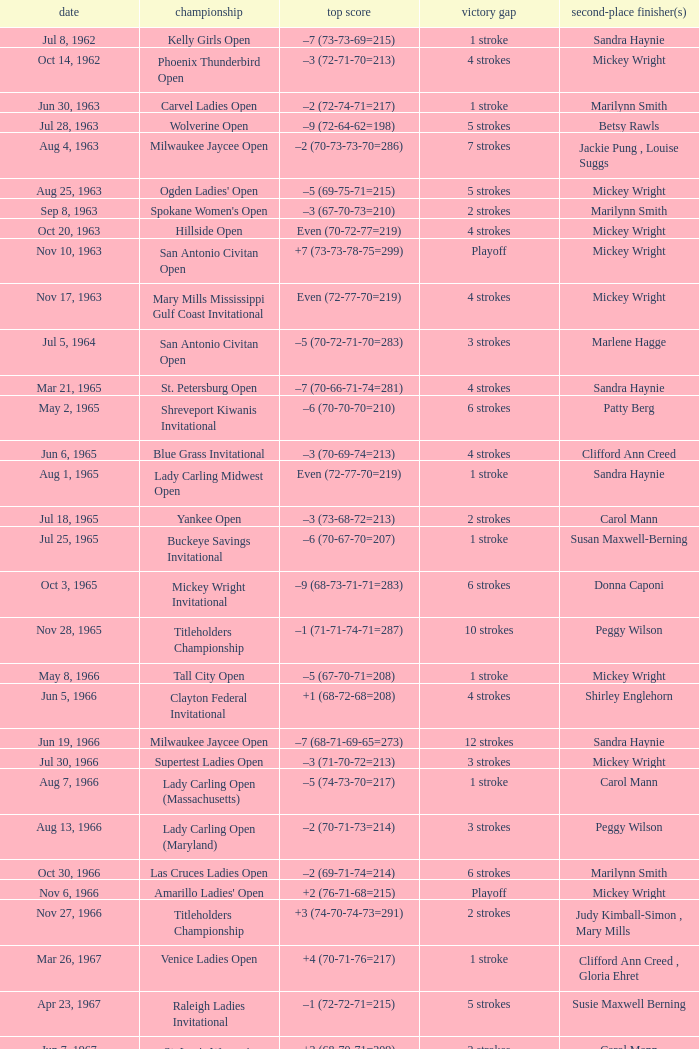How much did the winner surpass the runner-up by on april 23, 1967? 5 strokes. Could you parse the entire table as a dict? {'header': ['date', 'championship', 'top score', 'victory gap', 'second-place finisher(s)'], 'rows': [['Jul 8, 1962', 'Kelly Girls Open', '–7 (73-73-69=215)', '1 stroke', 'Sandra Haynie'], ['Oct 14, 1962', 'Phoenix Thunderbird Open', '–3 (72-71-70=213)', '4 strokes', 'Mickey Wright'], ['Jun 30, 1963', 'Carvel Ladies Open', '–2 (72-74-71=217)', '1 stroke', 'Marilynn Smith'], ['Jul 28, 1963', 'Wolverine Open', '–9 (72-64-62=198)', '5 strokes', 'Betsy Rawls'], ['Aug 4, 1963', 'Milwaukee Jaycee Open', '–2 (70-73-73-70=286)', '7 strokes', 'Jackie Pung , Louise Suggs'], ['Aug 25, 1963', "Ogden Ladies' Open", '–5 (69-75-71=215)', '5 strokes', 'Mickey Wright'], ['Sep 8, 1963', "Spokane Women's Open", '–3 (67-70-73=210)', '2 strokes', 'Marilynn Smith'], ['Oct 20, 1963', 'Hillside Open', 'Even (70-72-77=219)', '4 strokes', 'Mickey Wright'], ['Nov 10, 1963', 'San Antonio Civitan Open', '+7 (73-73-78-75=299)', 'Playoff', 'Mickey Wright'], ['Nov 17, 1963', 'Mary Mills Mississippi Gulf Coast Invitational', 'Even (72-77-70=219)', '4 strokes', 'Mickey Wright'], ['Jul 5, 1964', 'San Antonio Civitan Open', '–5 (70-72-71-70=283)', '3 strokes', 'Marlene Hagge'], ['Mar 21, 1965', 'St. Petersburg Open', '–7 (70-66-71-74=281)', '4 strokes', 'Sandra Haynie'], ['May 2, 1965', 'Shreveport Kiwanis Invitational', '–6 (70-70-70=210)', '6 strokes', 'Patty Berg'], ['Jun 6, 1965', 'Blue Grass Invitational', '–3 (70-69-74=213)', '4 strokes', 'Clifford Ann Creed'], ['Aug 1, 1965', 'Lady Carling Midwest Open', 'Even (72-77-70=219)', '1 stroke', 'Sandra Haynie'], ['Jul 18, 1965', 'Yankee Open', '–3 (73-68-72=213)', '2 strokes', 'Carol Mann'], ['Jul 25, 1965', 'Buckeye Savings Invitational', '–6 (70-67-70=207)', '1 stroke', 'Susan Maxwell-Berning'], ['Oct 3, 1965', 'Mickey Wright Invitational', '–9 (68-73-71-71=283)', '6 strokes', 'Donna Caponi'], ['Nov 28, 1965', 'Titleholders Championship', '–1 (71-71-74-71=287)', '10 strokes', 'Peggy Wilson'], ['May 8, 1966', 'Tall City Open', '–5 (67-70-71=208)', '1 stroke', 'Mickey Wright'], ['Jun 5, 1966', 'Clayton Federal Invitational', '+1 (68-72-68=208)', '4 strokes', 'Shirley Englehorn'], ['Jun 19, 1966', 'Milwaukee Jaycee Open', '–7 (68-71-69-65=273)', '12 strokes', 'Sandra Haynie'], ['Jul 30, 1966', 'Supertest Ladies Open', '–3 (71-70-72=213)', '3 strokes', 'Mickey Wright'], ['Aug 7, 1966', 'Lady Carling Open (Massachusetts)', '–5 (74-73-70=217)', '1 stroke', 'Carol Mann'], ['Aug 13, 1966', 'Lady Carling Open (Maryland)', '–2 (70-71-73=214)', '3 strokes', 'Peggy Wilson'], ['Oct 30, 1966', 'Las Cruces Ladies Open', '–2 (69-71-74=214)', '6 strokes', 'Marilynn Smith'], ['Nov 6, 1966', "Amarillo Ladies' Open", '+2 (76-71-68=215)', 'Playoff', 'Mickey Wright'], ['Nov 27, 1966', 'Titleholders Championship', '+3 (74-70-74-73=291)', '2 strokes', 'Judy Kimball-Simon , Mary Mills'], ['Mar 26, 1967', 'Venice Ladies Open', '+4 (70-71-76=217)', '1 stroke', 'Clifford Ann Creed , Gloria Ehret'], ['Apr 23, 1967', 'Raleigh Ladies Invitational', '–1 (72-72-71=215)', '5 strokes', 'Susie Maxwell Berning'], ['Jun 7, 1967', "St. Louis Women's Invitational", '+2 (68-70-71=209)', '2 strokes', 'Carol Mann'], ['Jul 16, 1967', 'LPGA Championship', '–8 (69-74-72-69=284)', '1 stroke', 'Shirley Englehorn'], ['Aug 6, 1967', 'Lady Carling Open (Ohio)', '–4 (71-70-71=212)', '1 stroke', 'Susie Maxwell Berning'], ['Aug 20, 1967', "Women's Western Open", '–11 (71-74-73-71=289)', '3 strokes', 'Sandra Haynie'], ['Oct 1, 1967', "Ladies' Los Angeles Open", '–4 (71-68-73=212)', '4 strokes', 'Murle Breer'], ['Oct 29, 1967', "Alamo Ladies' Open", '–3 (71-71-71=213)', '3 strokes', 'Sandra Haynie'], ['Mar 17, 1968', 'St. Petersburg Orange Blossom Open', 'Even (70-71-72=213)', '1 stroke', 'Sandra Haynie , Judy Kimball-Simon'], ['May 26, 1968', 'Dallas Civitan Open', '–4 (70-70-69=209)', '1 stroke', 'Carol Mann'], ['Jun 30, 1968', 'Lady Carling Open (Maryland)', '–2 (71-70-73=214)', '1 stroke', 'Carol Mann'], ['Aug 4, 1968', 'Gino Paoli Open', '–1 (69-72-74=215)', 'Playoff', 'Marlene Hagge'], ['Aug 18, 1968', 'Holiday Inn Classic', '–1 (74-70-62=206)', '3 strokes', 'Judy Kimball-Simon , Carol Mann'], ['Sep 22, 1968', 'Kings River Open', '–8 (68-71-69=208)', '10 strokes', 'Sandra Haynie'], ['Oct 22, 1968', 'River Plantation Invitational', '–8 (67-70-68=205)', '8 strokes', 'Kathy Cornelius'], ['Nov 3, 1968', 'Canyon Ladies Classic', '+2 (78-69-71=218)', '2 strokes', 'Donna Caponi , Shirley Englehorn , Mary Mills'], ['Nov 17, 1968', 'Pensacola Ladies Invitational', '–3 (71-71-74=216)', '3 strokes', 'Jo Ann Prentice ,'], ['Nov 24, 1968', 'Louise Suggs Invitational', '–8 (69-69-72=210)', '7 strokes', 'Carol Mann'], ['Mar 17, 1969', 'Orange Blossom Classic', '+3 (74-70-72=216)', 'Playoff', 'Shirley Englehorn , Marlene Hagge'], ['Mar 23, 1969', 'Port Charlotte Invitational', '–1 (72-72-74=218)', '1 stroke', 'Sandra Haynie , Sandra Post'], ['Mar 30, 1969', 'Port Malabar Invitational', '–3 (68-72-70=210)', '4 strokes', 'Mickey Wright'], ['Apr 20, 1969', 'Lady Carling Open (Georgia)', '–4 (70-72-70=212)', 'Playoff', 'Mickey Wright'], ['Jun 15, 1969', 'Patty Berg Classic', '–5 (69-73-72=214)', '1 stroke', 'Sandra Haynie'], ['Sep 14, 1969', 'Wendell-West Open', '–3 (69-72-72=213)', '1 stroke', 'Judy Rankin'], ['Nov 2, 1969', "River Plantation Women's Open", 'Even (70-71-72=213)', '1 stroke', 'Betsy Rawls'], ['Mar 22, 1970', 'Orange Blossom Classic', '+3 (73-72-71=216)', '1 stroke', 'Carol Mann'], ['Oct 18, 1970', "Quality Chek'd Classic", '–11 (71-67-67=205)', '3 strokes', 'JoAnne Carner'], ['Apr 18, 1971', 'Raleigh Golf Classic', '–4 (71-72-69=212)', '5 strokes', 'Pam Barnett'], ['May 23, 1971', 'Suzuki Golf Internationale', '+1 (72-72-73=217)', '2 strokes', 'Sandra Haynie , Sandra Palmer'], ['Jun 6, 1971', 'Lady Carling Open', '–9 (71-68-71=210)', '6 strokes', 'Jane Blalock'], ['Jun 13, 1971', 'Eve-LPGA Championship', '–4 (71-73-70-74=288)', '4 strokes', 'Kathy Ahern'], ['Apr 30, 1972', 'Alamo Ladies Open', '–10 (66-71-72=209)', '3 strokes', 'Mickey Wright'], ['Jul 23, 1972', 'Raleigh Golf Classic', '–4 (72-69-71=212)', '2 strokes', 'Marilynn Smith'], ['Aug 6, 1972', 'Knoxville Ladies Classic', '–4 (71-68-71=210)', '4 strokes', 'Sandra Haynie'], ['Aug 20, 1972', 'Southgate Ladies Open', 'Even (69-71-76=216)', 'Playoff', 'Jocelyne Bourassa'], ['Oct 1, 1972', 'Portland Ladies Open', '–7 (75-69-68=212)', '4 strokes', 'Sandra Haynie'], ['Feb 11, 1973', 'Naples Lely Classic', '+3 (68-76-75=219)', '2 strokes', 'JoAnne Carner'], ['Mar 11, 1973', 'S&H Green Stamp Classic', '–2 (73-71-70=214)', '2 strokes', 'Mary Mills'], ['Sep 9, 1973', 'Dallas Civitan Open', '–3 (75-72-66=213)', 'Playoff', 'Mary Mills'], ['Sep 16, 1973', 'Southgate Ladies Open', '–2 (72-70=142)', '1 stroke', 'Gerda Boykin'], ['Sep 23, 1973', 'Portland Ladies Open', '–2 (71-73=144)', '2 strokes', 'Sandra Palmer'], ['Oct 21, 1973', 'Waco Tribune Herald Ladies Classic', '–7 (68-72-69=209)', '4 strokes', 'Kathy Cornelius , Pam Higgins , Marilynn Smith'], ['Nov 4, 1973', 'Lady Errol Classic', '–3 (68-75-70=213)', '2 strokes', 'Gloria Ehret , Shelley Hamlin'], ['Mar 3, 1974', 'Orange Blossom Classic', '–7 (70-68-71=209)', '1 stroke', 'Sandra Haynie'], ['Jun 1, 1975', 'LPGA Championship', '–4 (70-70-75-73=288)', '1 stroke', 'Sandra Haynie'], ['Sep 14, 1975', 'Southgate Open', 'Even (72-72-69=213)', '4 strokes', 'Gerda Boykin'], ['Feb 7, 1976', 'Bent Tree Classic', '–7 (69-69-71=209)', '1 stroke', 'Hollis Stacy'], ['Aug 22, 1976', 'Patty Berg Classic', '–7 (66-73-73=212)', '2 strokes', 'Sandra Post'], ['Apr 3, 1977', "Colgate-Dinah Shore Winner's Circle", '+1 (76-70-72-71=289)', '1 stroke', 'Joanne Carner , Sally Little'], ['Apr 24, 1977', 'American Defender Classic', '–10 (69-68-69=206)', '1 stroke', 'Pat Bradley'], ['May 22, 1977', 'LPGA Coca-Cola Classic', '–11 (67-68-67=202)', '3 strokes', 'Donna Caponi'], ['Sep 10, 1978', 'National Jewish Hospital Open', '–5 (70-75-66-65=276)', '3 strokes', 'Pat Bradley , Gloria Ehret , JoAnn Washam'], ['May 17, 1981', 'Coca-Cola Classic', '–8 (69-72-70=211)', 'Playoff', 'Alice Ritzman'], ['Apr 18, 1982', "CPC Women's International", '–7 (73-68-73-67=281)', '9 strokes', 'Patty Sheehan'], ['May 16, 1982', 'Lady Michelob', '–9 (69-68-70=207)', '4 strokes', 'Sharon Barrett Barbara Moxness'], ['Mar 20, 1983', "Women's Kemper Open", '–4 (72-77-70-69=288)', '1 stroke', 'Dale Eggeling'], ['Jul 22, 1984', 'Rochester International', '–7 (73-68-71-69=281)', 'Playoff', 'Rosie Jones'], ['Sep 16, 1984', 'Safeco Classic', '–9 (69-75-65-70=279)', '2 strokes', 'Laura Baugh , Marta Figueras-Dotti'], ['Oct 14, 1984', 'Smirnoff Ladies Irish Open', '–3 (70-74-69-72=285)', '2 strokes', 'Pat Bradley , Becky Pearson'], ['May 12, 1985', 'United Virginia Bank Classic', '–9 (69-66-72=207)', '1 stroke', 'Amy Alcott']]} 